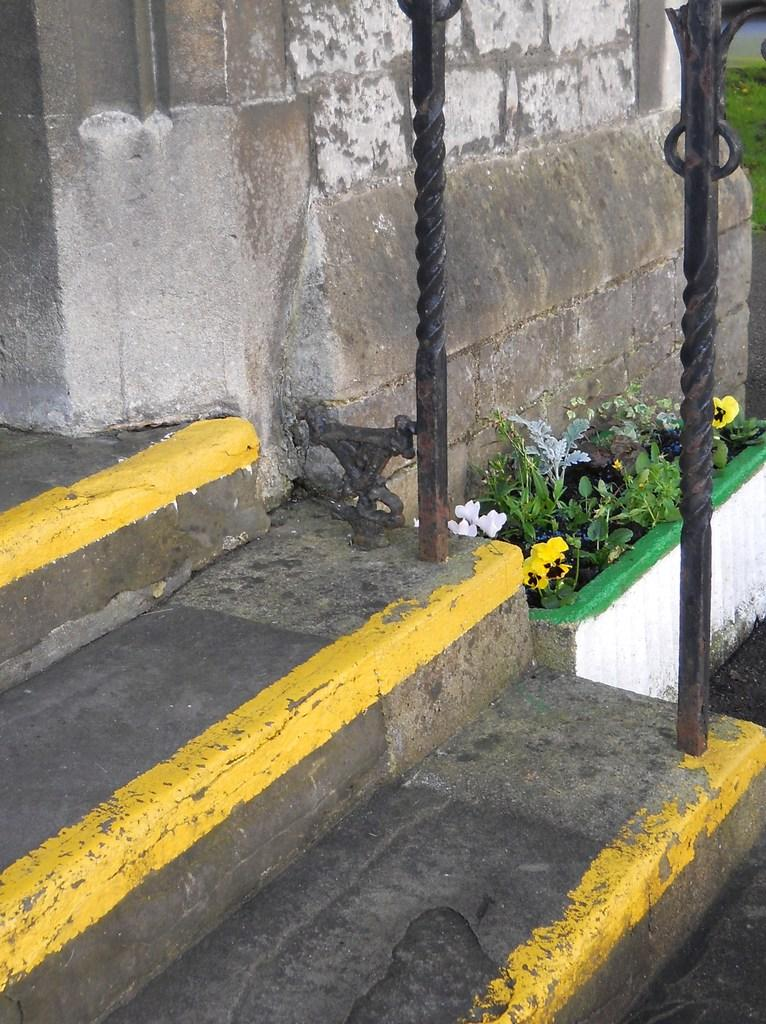What is located at the bottom of the image? There are stairs at the bottom of the image. What can be seen in the middle of the image? Flower plants are present in the middle of the image. What is visible in the background of the image? There is a wall in the background of the image. What type of appliance can be seen plugged into the wall in the image? There is no appliance visible in the image; it only features stairs, flower plants, and a wall. Can you describe the veins of the flower plants in the image? There are no visible veins on the flower plants in the image, as the image does not show a close-up view of the plants. 